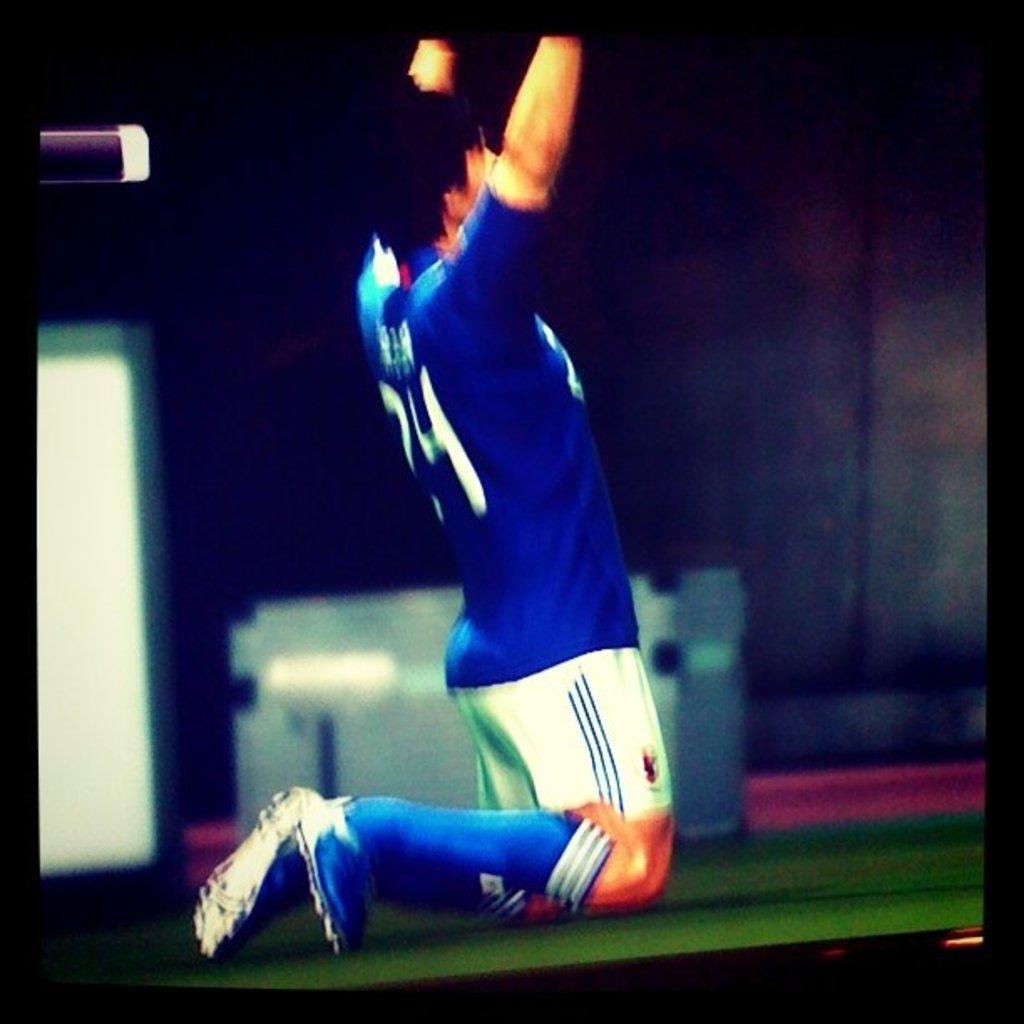What is the main subject of the image? There is a person in the image. Can you describe the background of the image? The background of the image is blurry. What else can be seen in the background of the image? There are unspecified things in the background of the image. What type of nut is being cracked by the kitty in the image? There is no kitty or nut present in the image; it features a person with a blurry background. Can you tell me how many tigers are visible in the image? There are no tigers visible in the image; it features a person with a blurry background. 